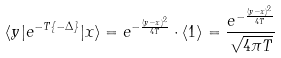<formula> <loc_0><loc_0><loc_500><loc_500>\langle y | e ^ { - T \left \{ - \Delta \right \} } | x \rangle = e ^ { - \frac { ( y - x ) ^ { 2 } } { 4 T } } \cdot \langle 1 \rangle = \frac { e ^ { - \frac { ( y - x ) ^ { 2 } } { 4 T } } } { \sqrt { 4 \pi T } }</formula> 